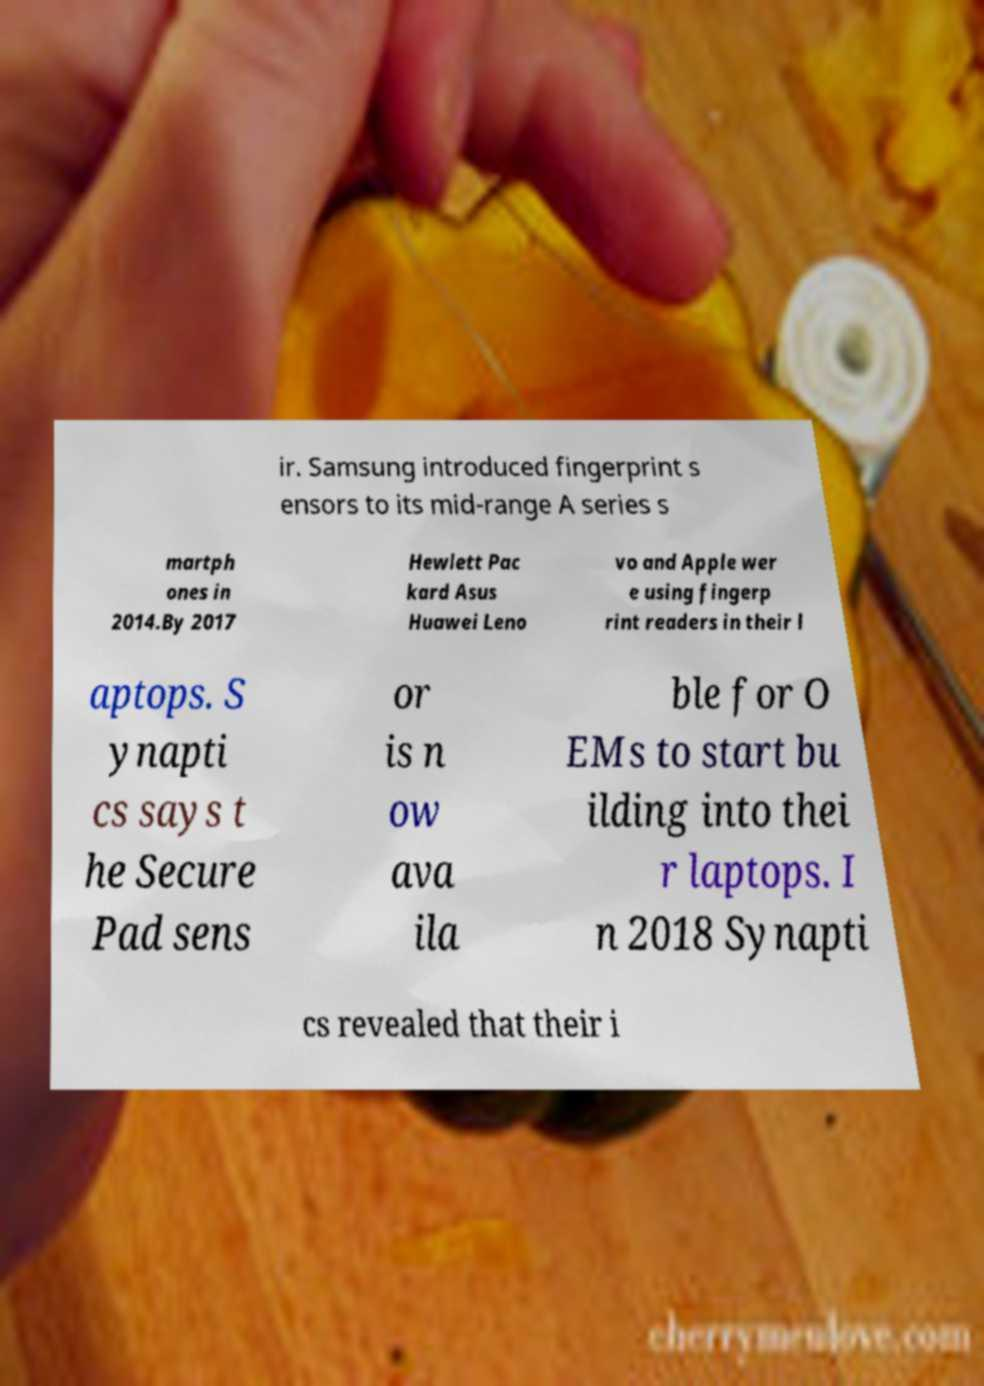Could you assist in decoding the text presented in this image and type it out clearly? ir. Samsung introduced fingerprint s ensors to its mid-range A series s martph ones in 2014.By 2017 Hewlett Pac kard Asus Huawei Leno vo and Apple wer e using fingerp rint readers in their l aptops. S ynapti cs says t he Secure Pad sens or is n ow ava ila ble for O EMs to start bu ilding into thei r laptops. I n 2018 Synapti cs revealed that their i 